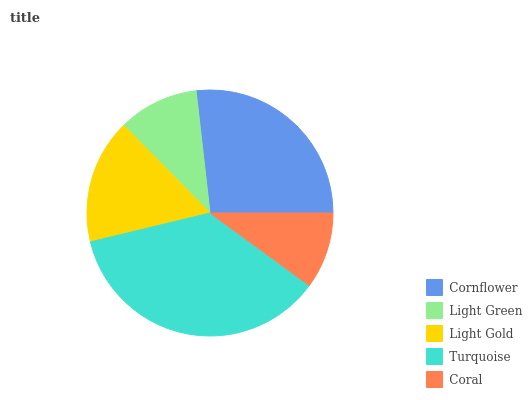Is Coral the minimum?
Answer yes or no. Yes. Is Turquoise the maximum?
Answer yes or no. Yes. Is Light Green the minimum?
Answer yes or no. No. Is Light Green the maximum?
Answer yes or no. No. Is Cornflower greater than Light Green?
Answer yes or no. Yes. Is Light Green less than Cornflower?
Answer yes or no. Yes. Is Light Green greater than Cornflower?
Answer yes or no. No. Is Cornflower less than Light Green?
Answer yes or no. No. Is Light Gold the high median?
Answer yes or no. Yes. Is Light Gold the low median?
Answer yes or no. Yes. Is Cornflower the high median?
Answer yes or no. No. Is Light Green the low median?
Answer yes or no. No. 